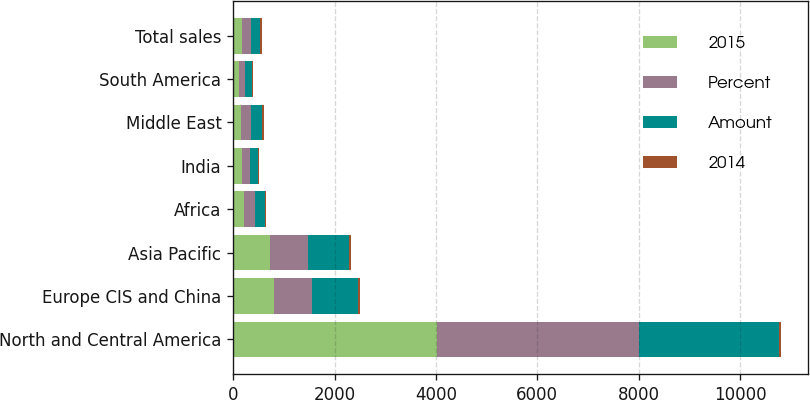Convert chart to OTSL. <chart><loc_0><loc_0><loc_500><loc_500><stacked_bar_chart><ecel><fcel>North and Central America<fcel>Europe CIS and China<fcel>Asia Pacific<fcel>Africa<fcel>India<fcel>Middle East<fcel>South America<fcel>Total sales<nl><fcel>2015<fcel>4015<fcel>798<fcel>720<fcel>206<fcel>175<fcel>160<fcel>107<fcel>175<nl><fcel>Percent<fcel>3992<fcel>758<fcel>763<fcel>232<fcel>165<fcel>199<fcel>120<fcel>175<nl><fcel>Amount<fcel>2765<fcel>908<fcel>794<fcel>187<fcel>157<fcel>208<fcel>155<fcel>175<nl><fcel>2014<fcel>23<fcel>40<fcel>43<fcel>26<fcel>10<fcel>39<fcel>13<fcel>48<nl></chart> 